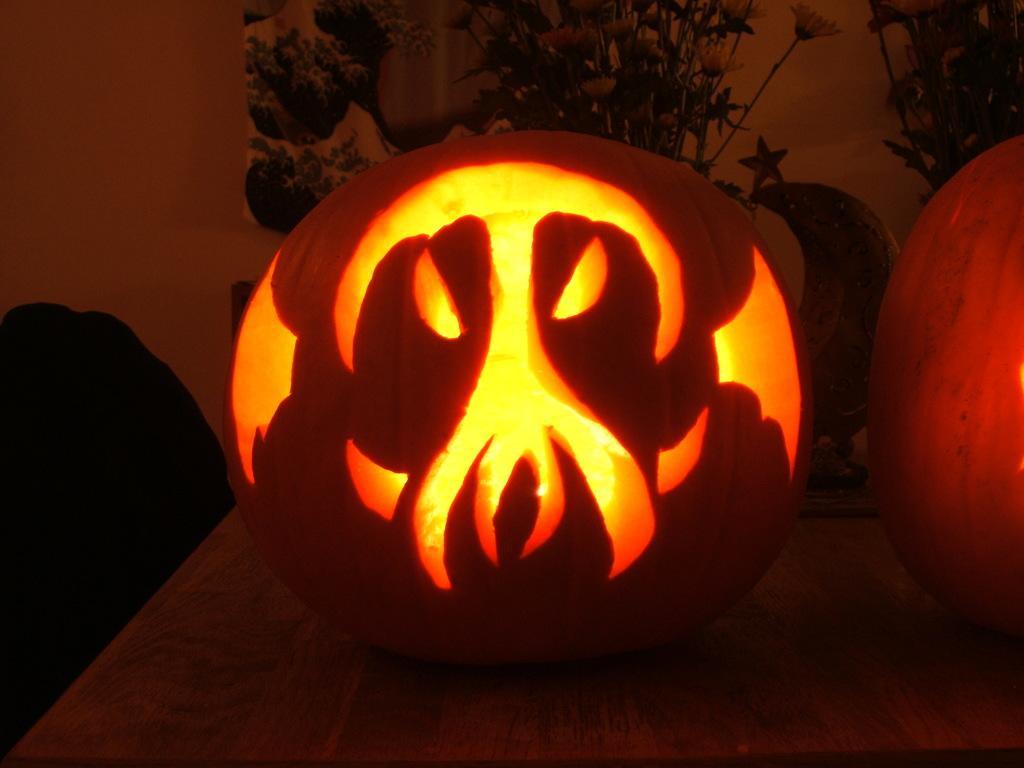Can you describe this image briefly? In this image we can see two pumpkins placed on the table. In the background, we can see group of flowers, a star and a sculpture. 